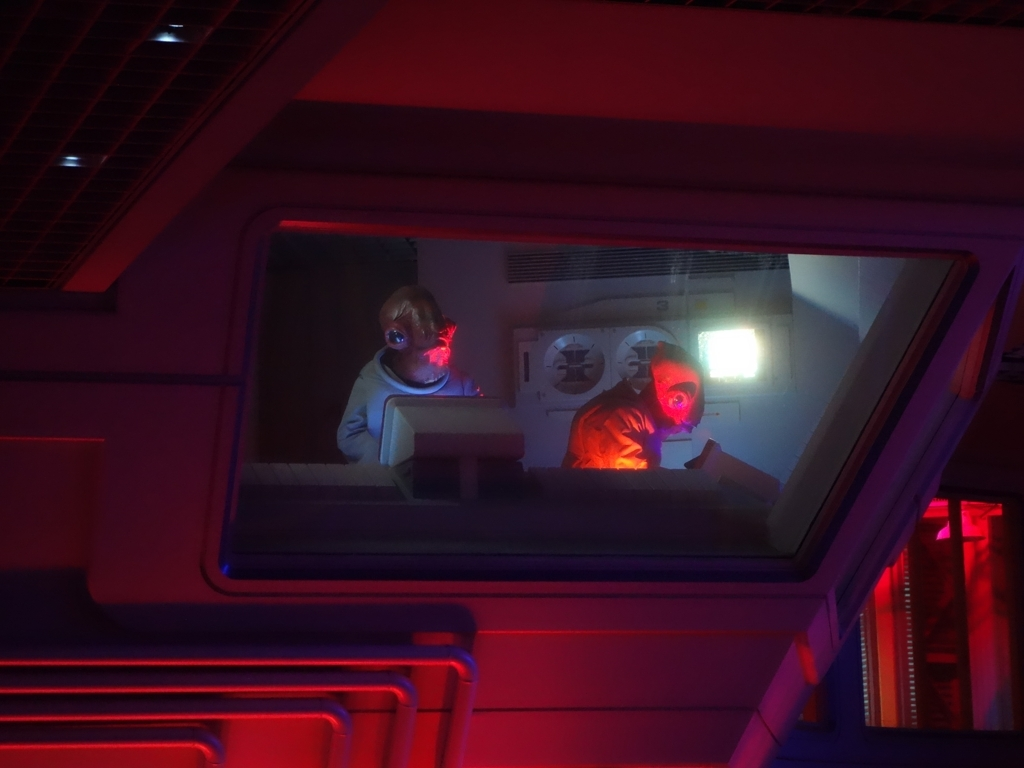How would you describe the composition of this image?
A. good
B. poor
C. average The composition of this image could be described as good (A). The use of dynamic lighting adds depth and drama to the scene, highlighting the subjects and creating a moody atmosphere. The perspective through the window adds an element of curiosity, inviting the viewer to ponder the narrative or story behind what's depicted. Furthermore, the framing and positioning of subjects within the environment are well executed, contributing to a sense of spatial balance within this cinematic composition. 